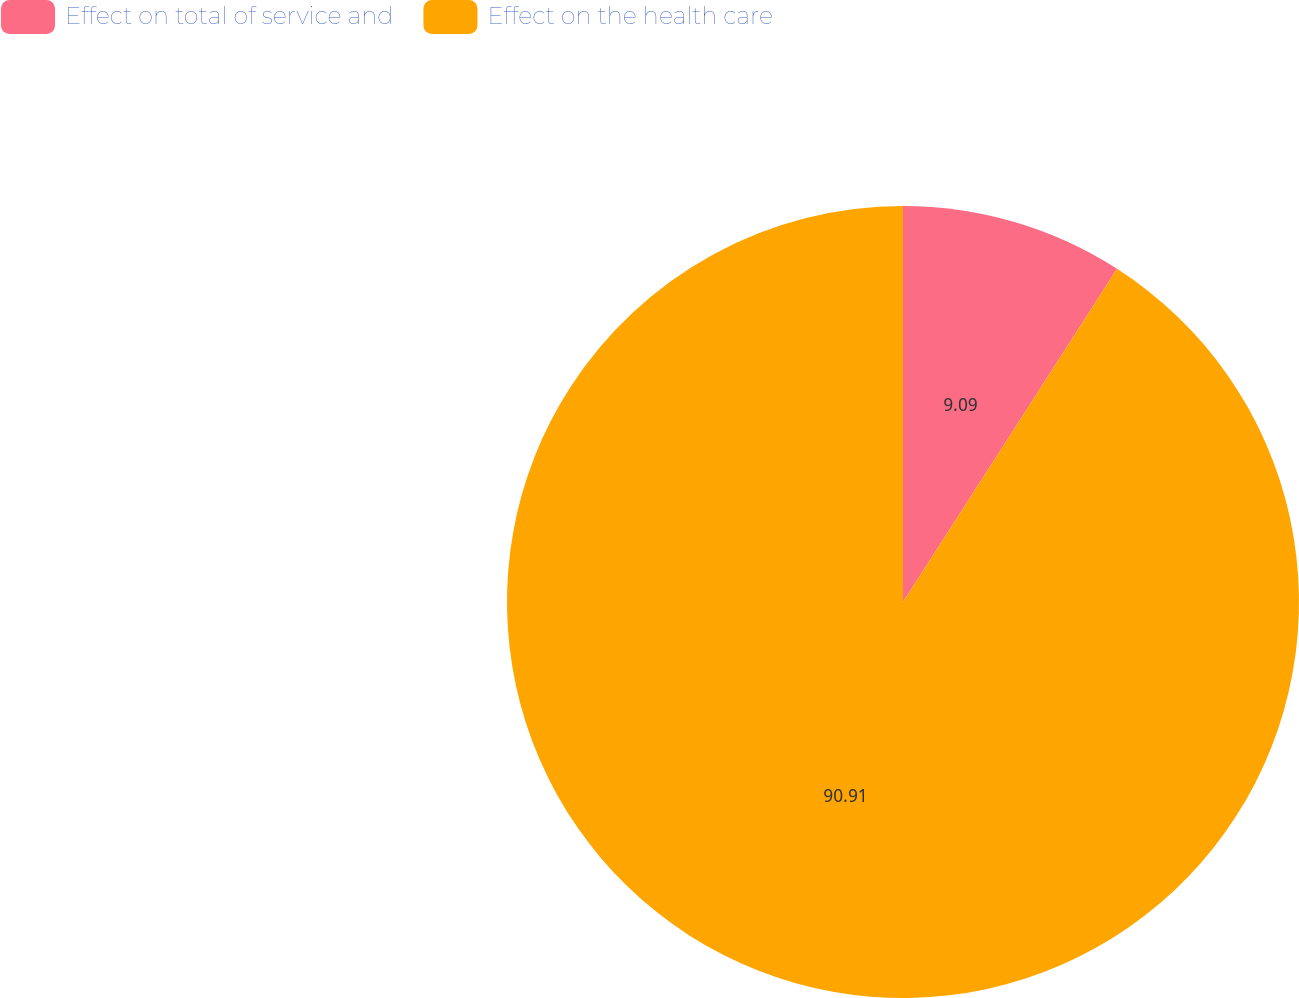<chart> <loc_0><loc_0><loc_500><loc_500><pie_chart><fcel>Effect on total of service and<fcel>Effect on the health care<nl><fcel>9.09%<fcel>90.91%<nl></chart> 